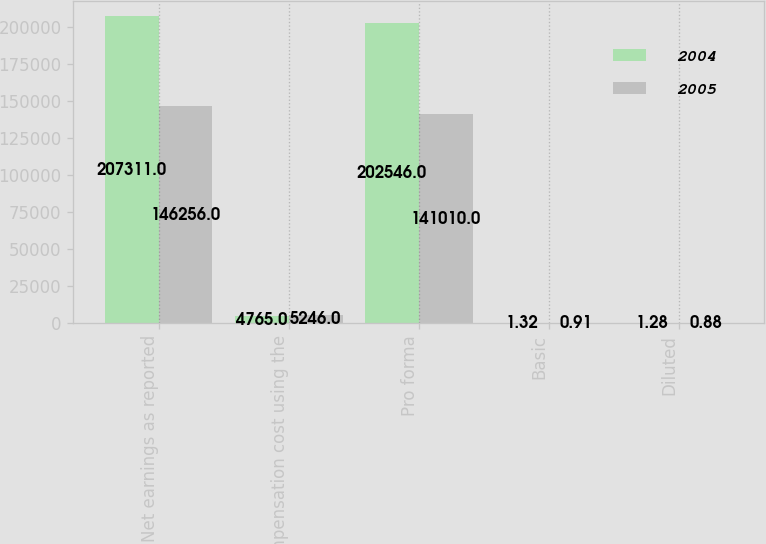Convert chart. <chart><loc_0><loc_0><loc_500><loc_500><stacked_bar_chart><ecel><fcel>Net earnings as reported<fcel>Compensation cost using the<fcel>Pro forma<fcel>Basic<fcel>Diluted<nl><fcel>2004<fcel>207311<fcel>4765<fcel>202546<fcel>1.32<fcel>1.28<nl><fcel>2005<fcel>146256<fcel>5246<fcel>141010<fcel>0.91<fcel>0.88<nl></chart> 